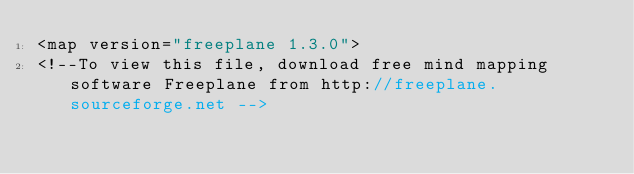<code> <loc_0><loc_0><loc_500><loc_500><_ObjectiveC_><map version="freeplane 1.3.0">
<!--To view this file, download free mind mapping software Freeplane from http://freeplane.sourceforge.net --></code> 